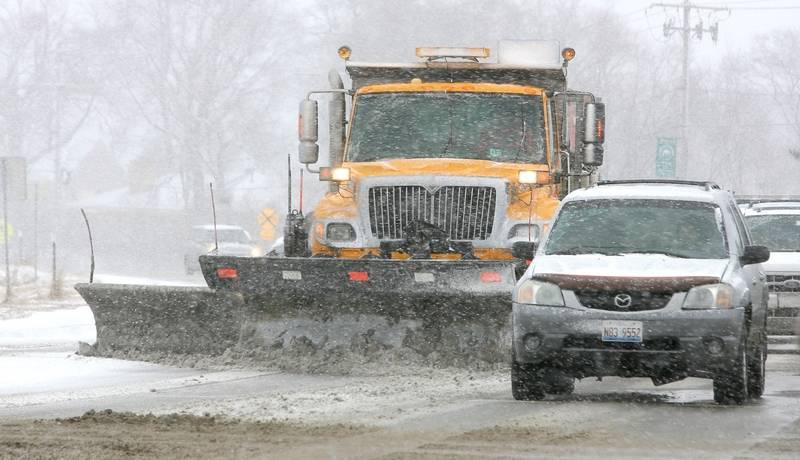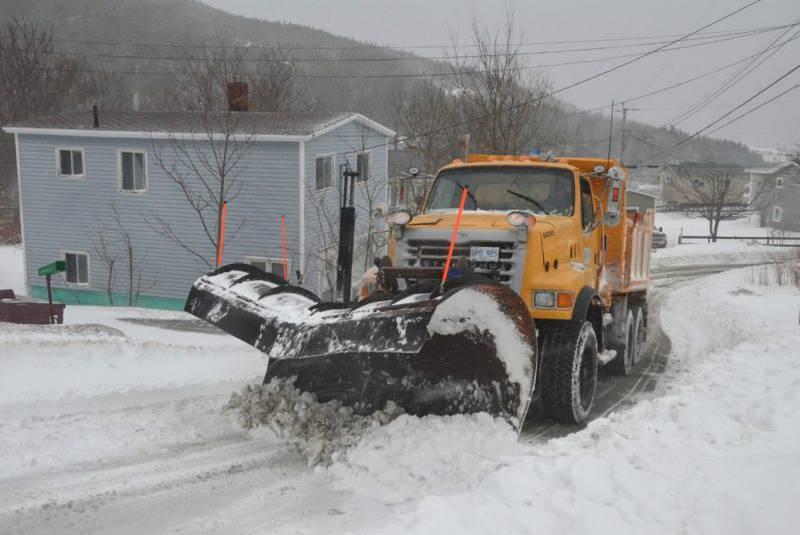The first image is the image on the left, the second image is the image on the right. Evaluate the accuracy of this statement regarding the images: "There is a white vehicle.". Is it true? Answer yes or no. Yes. The first image is the image on the left, the second image is the image on the right. Examine the images to the left and right. Is the description "The left and right image contains the same number of snow scraper trucks plowing a road." accurate? Answer yes or no. Yes. 